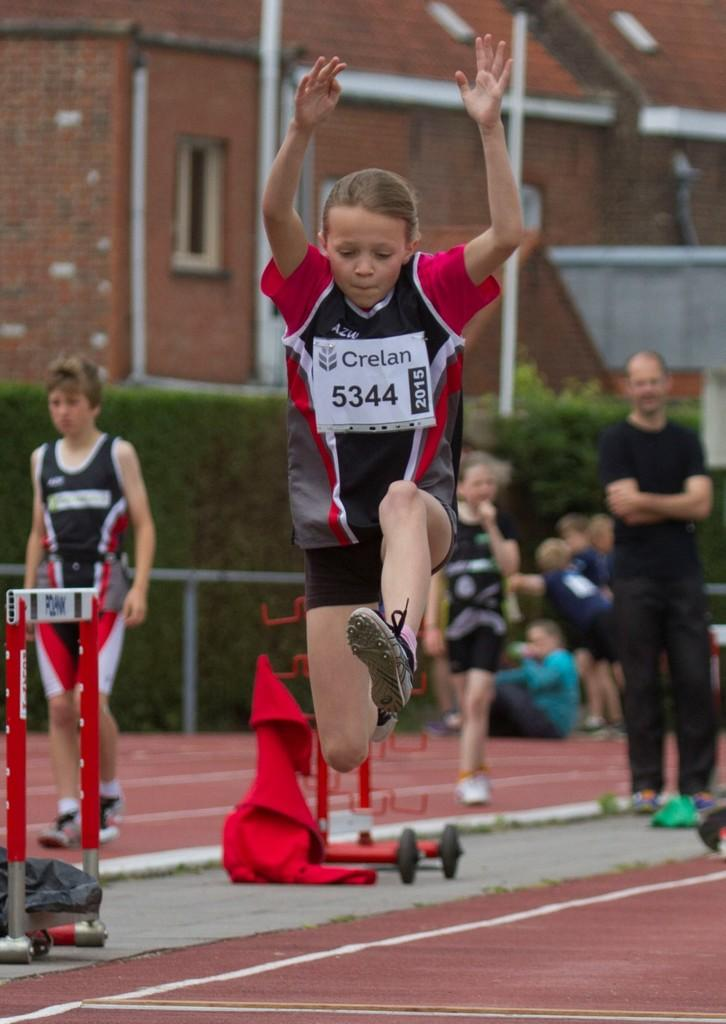What type of structure is present in the image? There is a building in the image. What type of vegetation is visible in the image? There are plants in the image. Can you describe the people present in the image? There are people in the image. What other objects can be seen in the image? There are some other objects in the image. What type of jam is being spread on the dock in the image? There is no jam or dock present in the image. What type of book is being read by the people in the image? There is no book present in the image. 